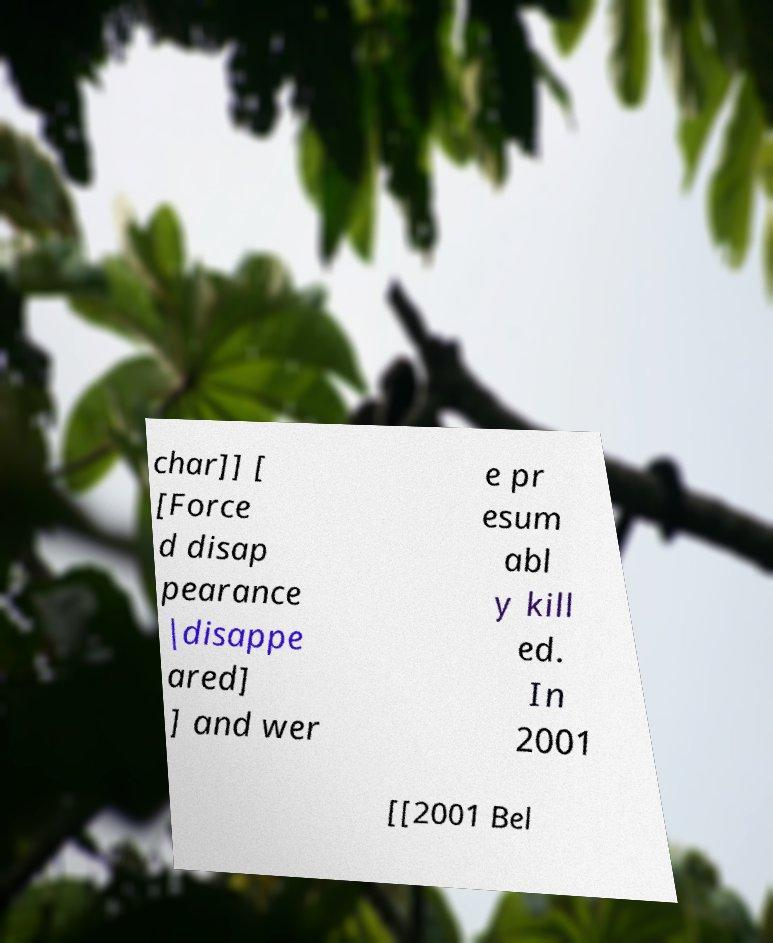For documentation purposes, I need the text within this image transcribed. Could you provide that? char]] [ [Force d disap pearance |disappe ared] ] and wer e pr esum abl y kill ed. In 2001 [[2001 Bel 